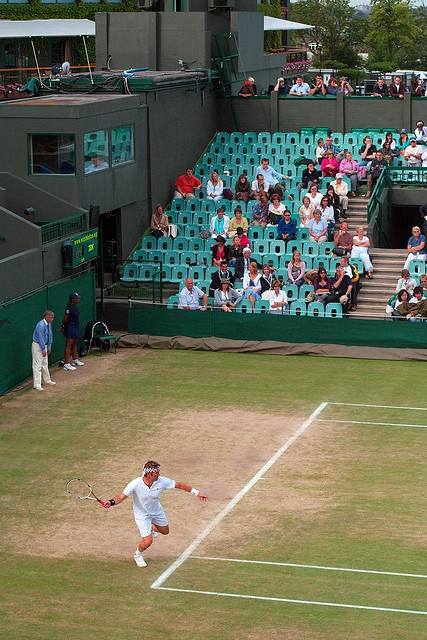Describe the objects in this image and their specific colors. I can see people in teal, black, gray, and lightgray tones, chair in teal and black tones, people in teal, lavender, darkgray, and tan tones, people in teal, darkgray, gray, and lightgray tones, and chair in teal and black tones in this image. 